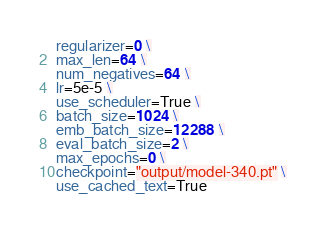Convert code to text. <code><loc_0><loc_0><loc_500><loc_500><_Bash_>regularizer=0 \
max_len=64 \
num_negatives=64 \
lr=5e-5 \
use_scheduler=True \
batch_size=1024 \
emb_batch_size=12288 \
eval_batch_size=2 \
max_epochs=0 \
checkpoint="output/model-340.pt" \
use_cached_text=True
</code> 